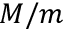<formula> <loc_0><loc_0><loc_500><loc_500>M / m</formula> 